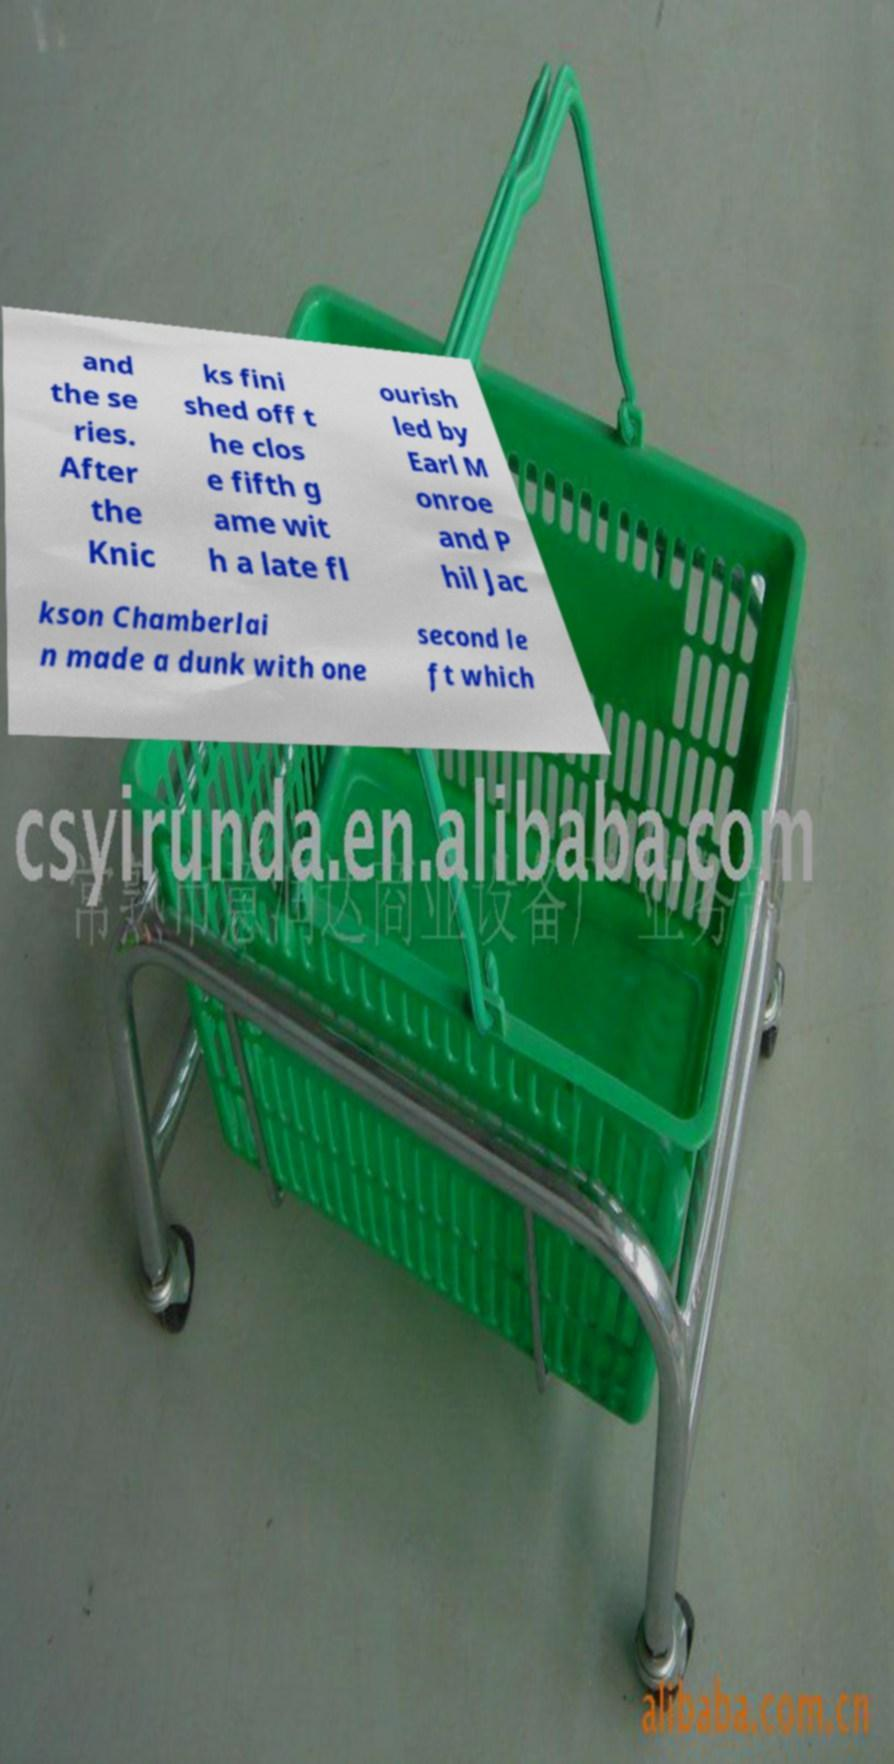Could you assist in decoding the text presented in this image and type it out clearly? and the se ries. After the Knic ks fini shed off t he clos e fifth g ame wit h a late fl ourish led by Earl M onroe and P hil Jac kson Chamberlai n made a dunk with one second le ft which 